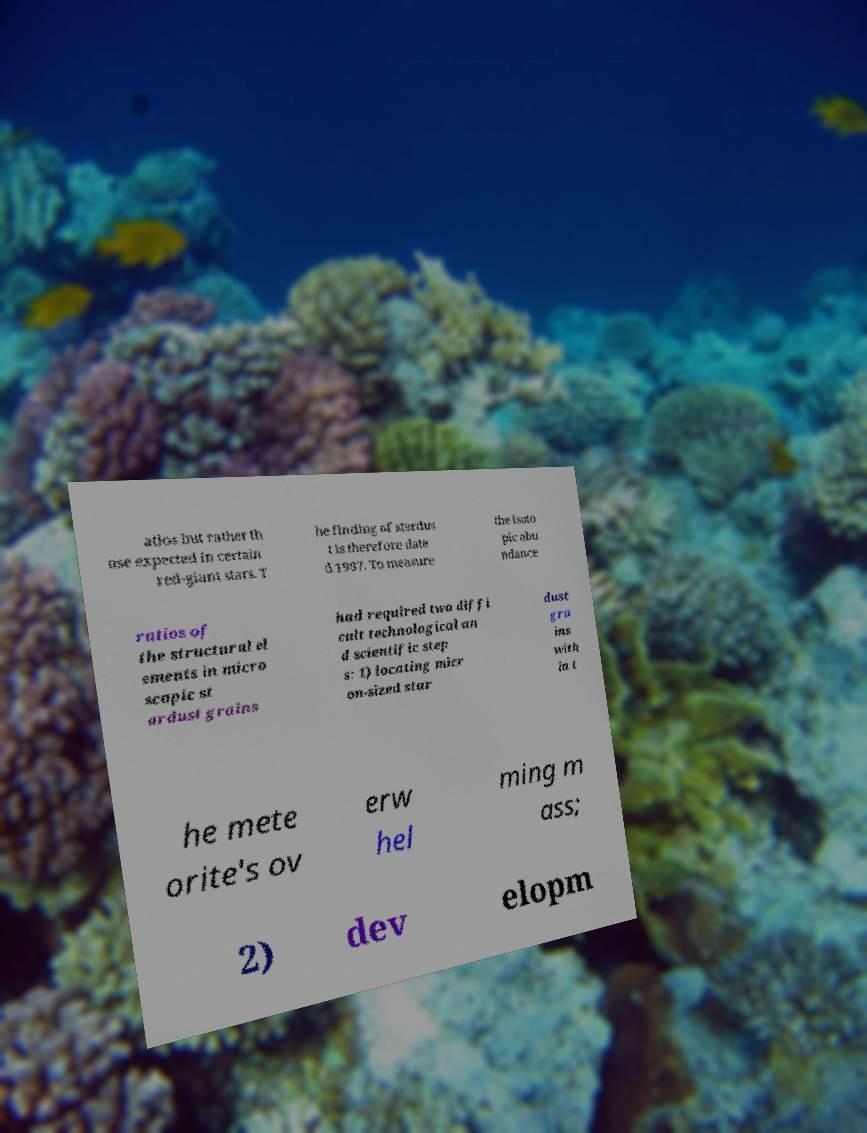Can you accurately transcribe the text from the provided image for me? atios but rather th ose expected in certain red-giant stars. T he finding of stardus t is therefore date d 1987. To measure the isoto pic abu ndance ratios of the structural el ements in micro scopic st ardust grains had required two diffi cult technological an d scientific step s: 1) locating micr on-sized star dust gra ins with in t he mete orite's ov erw hel ming m ass; 2) dev elopm 